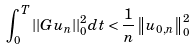Convert formula to latex. <formula><loc_0><loc_0><loc_500><loc_500>\int _ { 0 } ^ { T } | | G u _ { n } | | _ { 0 } ^ { 2 } d t < \frac { 1 } { n } \left \| u _ { 0 , n } \right \| _ { 0 } ^ { 2 }</formula> 